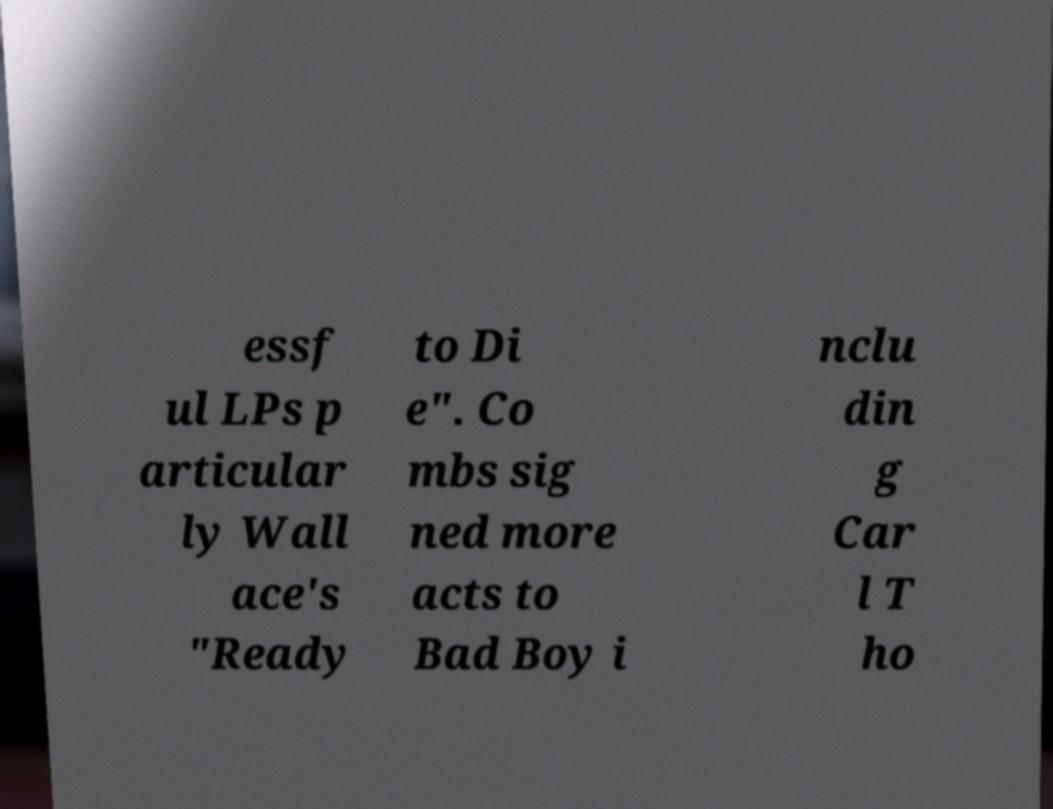What messages or text are displayed in this image? I need them in a readable, typed format. essf ul LPs p articular ly Wall ace's "Ready to Di e". Co mbs sig ned more acts to Bad Boy i nclu din g Car l T ho 